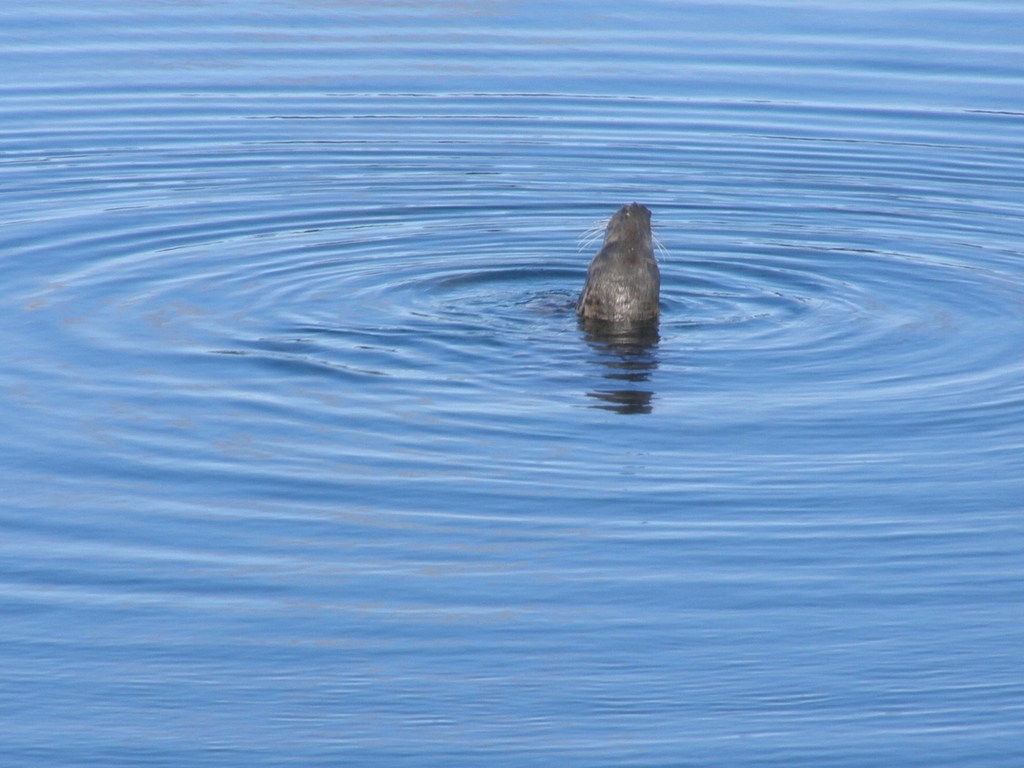What time of day does this image seem to capture, based on the lighting and shadows? The lighting in the image has a soft quality, with the sunlight creating a uniform illumination and gentle reflections on the water. This could suggest that the photo was taken either in the mid-morning or late afternoon, when the sun is not at its peak, thus avoiding harsh shadows and strong contrasts. 